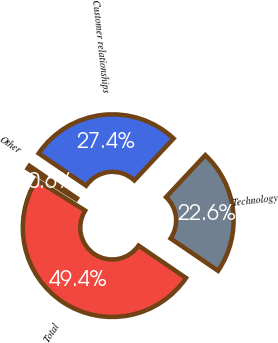<chart> <loc_0><loc_0><loc_500><loc_500><pie_chart><fcel>Technology<fcel>Customer relationships<fcel>Other<fcel>Total<nl><fcel>22.56%<fcel>27.44%<fcel>0.6%<fcel>49.39%<nl></chart> 